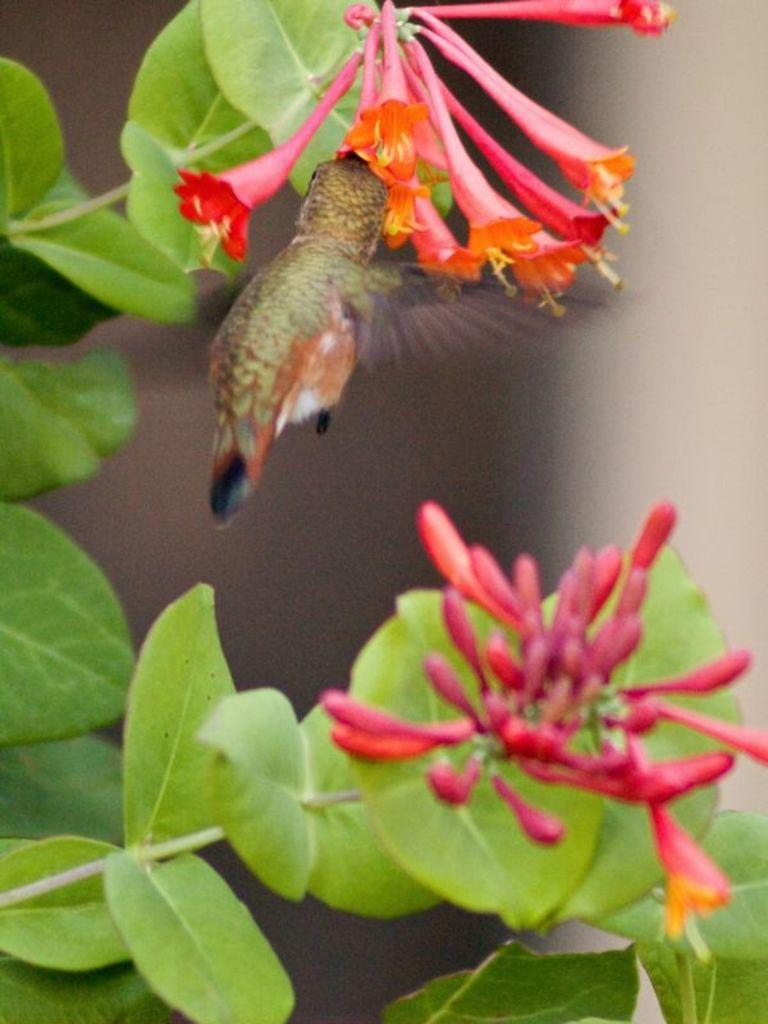What type of plant life can be seen in the image? There are leaves and flowers in the image. Is there any wildlife present in the image? Yes, there is an insect on a flower in the image. How many pairs of shoes can be seen in the image? There are no shoes present in the image. What type of lizards can be seen in the image? There are no lizards present in the image. 